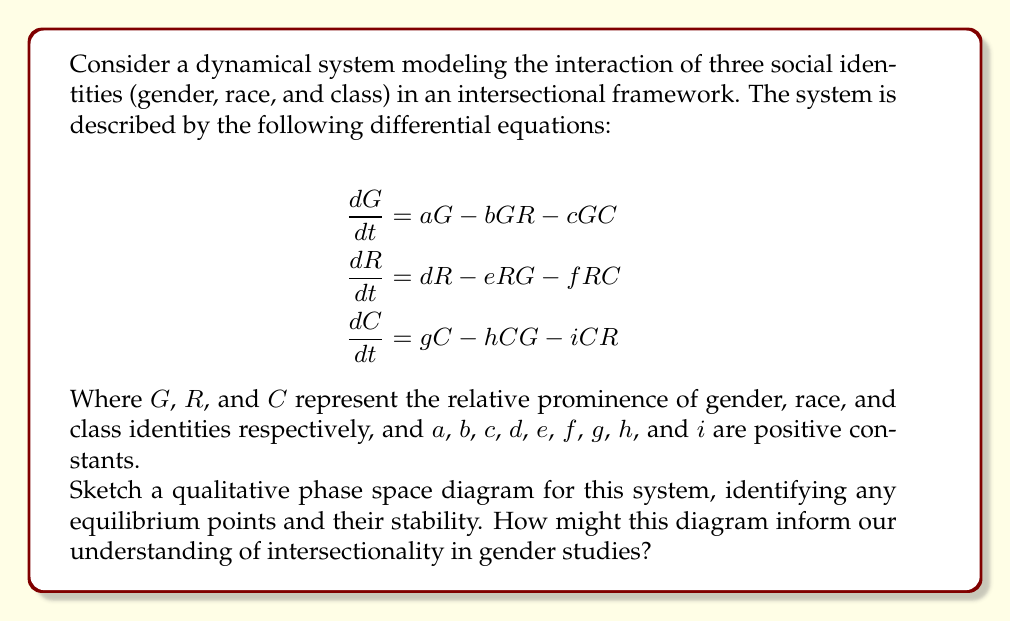Provide a solution to this math problem. To answer this question, we'll follow these steps:

1) Identify the equilibrium points:
   Set $\frac{dG}{dt} = \frac{dR}{dt} = \frac{dC}{dt} = 0$ and solve for $G$, $R$, and $C$.

   We have three trivial equilibrium points:
   $(0,0,0)$, $(a/b,0,0)$, $(0,d/e,0)$, and $(0,0,g/h)$

   There might be other equilibrium points where two or all three variables are non-zero, but their exact values depend on the specific parameter values.

2) Determine the stability of these points:
   This would typically involve linearizing the system around each point and analyzing the eigenvalues of the Jacobian matrix. However, for a qualitative sketch, we can use the following observations:

   - $(0,0,0)$ is likely unstable, as any small perturbation in one identity would lead to growth.
   - The single-identity equilibrium points (like $(a/b,0,0)$) might be semi-stable, stable along their axis but unstable to perturbations in other directions.
   - There might be a stable equilibrium point where all three identities coexist, representing a balanced intersectional state.

3) Sketch the phase space:
   
[asy]
import graph3;
size(200);
currentprojection=perspective(6,3,2);

// axes
draw((0,0,0)--(2,0,0),arrow=Arrow3);
draw((0,0,0)--(0,2,0),arrow=Arrow3);
draw((0,0,0)--(0,0,2),arrow=Arrow3);

// labels
label("G", (2.2,0,0));
label("R", (0,2.2,0));
label("C", (0,0,2.2));

// equilibrium points
dot((0,0,0));
dot((1.5,0,0));
dot((0,1.5,0));
dot((0,0,1.5));
dot((1,1,1));

// sample trajectories
path3 p1=((0.2,0.2,0.2)..(0.5,0.5,0.5)..(1,1,1));
path3 p2=((1.8,0.1,0.1)..(1.5,0.5,0.5)..(1,1,1));
path3 p3=((0.1,1.8,0.1)..(0.5,1.5,0.5)..(1,1,1));

draw(p1,arrow=Arrow3);
draw(p2,arrow=Arrow3);
draw(p3,arrow=Arrow3);
[/asy]

4) Interpret the diagram:
   - The origin $(0,0,0)$ represents a state where none of the identities are prominent.
   - The axes represent states dominated by a single identity.
   - The interior of the first octant represents states where all identities are present to varying degrees.
   - Trajectories tend to move away from the origin and the axes, and towards an equilibrium point in the interior, representing a balanced intersectional state.

This phase space diagram informs our understanding of intersectionality in gender studies by:
   - Illustrating the dynamic nature of identity prominence
   - Showing how focusing on a single identity (represented by points on the axes) is unstable
   - Demonstrating that a balanced state where all identities are acknowledged (the interior equilibrium point) is more stable
   - Revealing how changes in one identity dimension can affect the others, representing the interconnected nature of intersectionality
Answer: The phase space diagram shows unstable equilibria at $(0,0,0)$ and along the axes, with a stable equilibrium in the interior, representing a balanced intersectional state. 